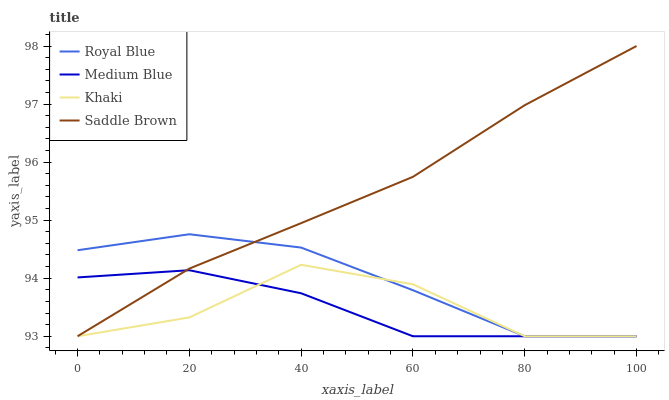Does Medium Blue have the minimum area under the curve?
Answer yes or no. Yes. Does Saddle Brown have the maximum area under the curve?
Answer yes or no. Yes. Does Khaki have the minimum area under the curve?
Answer yes or no. No. Does Khaki have the maximum area under the curve?
Answer yes or no. No. Is Saddle Brown the smoothest?
Answer yes or no. Yes. Is Khaki the roughest?
Answer yes or no. Yes. Is Medium Blue the smoothest?
Answer yes or no. No. Is Medium Blue the roughest?
Answer yes or no. No. Does Royal Blue have the lowest value?
Answer yes or no. Yes. Does Saddle Brown have the highest value?
Answer yes or no. Yes. Does Khaki have the highest value?
Answer yes or no. No. Does Medium Blue intersect Saddle Brown?
Answer yes or no. Yes. Is Medium Blue less than Saddle Brown?
Answer yes or no. No. Is Medium Blue greater than Saddle Brown?
Answer yes or no. No. 